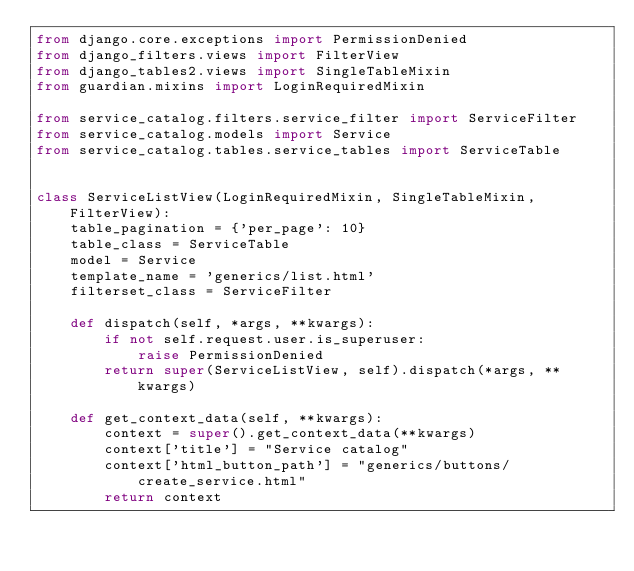<code> <loc_0><loc_0><loc_500><loc_500><_Python_>from django.core.exceptions import PermissionDenied
from django_filters.views import FilterView
from django_tables2.views import SingleTableMixin
from guardian.mixins import LoginRequiredMixin

from service_catalog.filters.service_filter import ServiceFilter
from service_catalog.models import Service
from service_catalog.tables.service_tables import ServiceTable


class ServiceListView(LoginRequiredMixin, SingleTableMixin, FilterView):
    table_pagination = {'per_page': 10}
    table_class = ServiceTable
    model = Service
    template_name = 'generics/list.html'
    filterset_class = ServiceFilter

    def dispatch(self, *args, **kwargs):
        if not self.request.user.is_superuser:
            raise PermissionDenied
        return super(ServiceListView, self).dispatch(*args, **kwargs)

    def get_context_data(self, **kwargs):
        context = super().get_context_data(**kwargs)
        context['title'] = "Service catalog"
        context['html_button_path'] = "generics/buttons/create_service.html"
        return context
</code> 